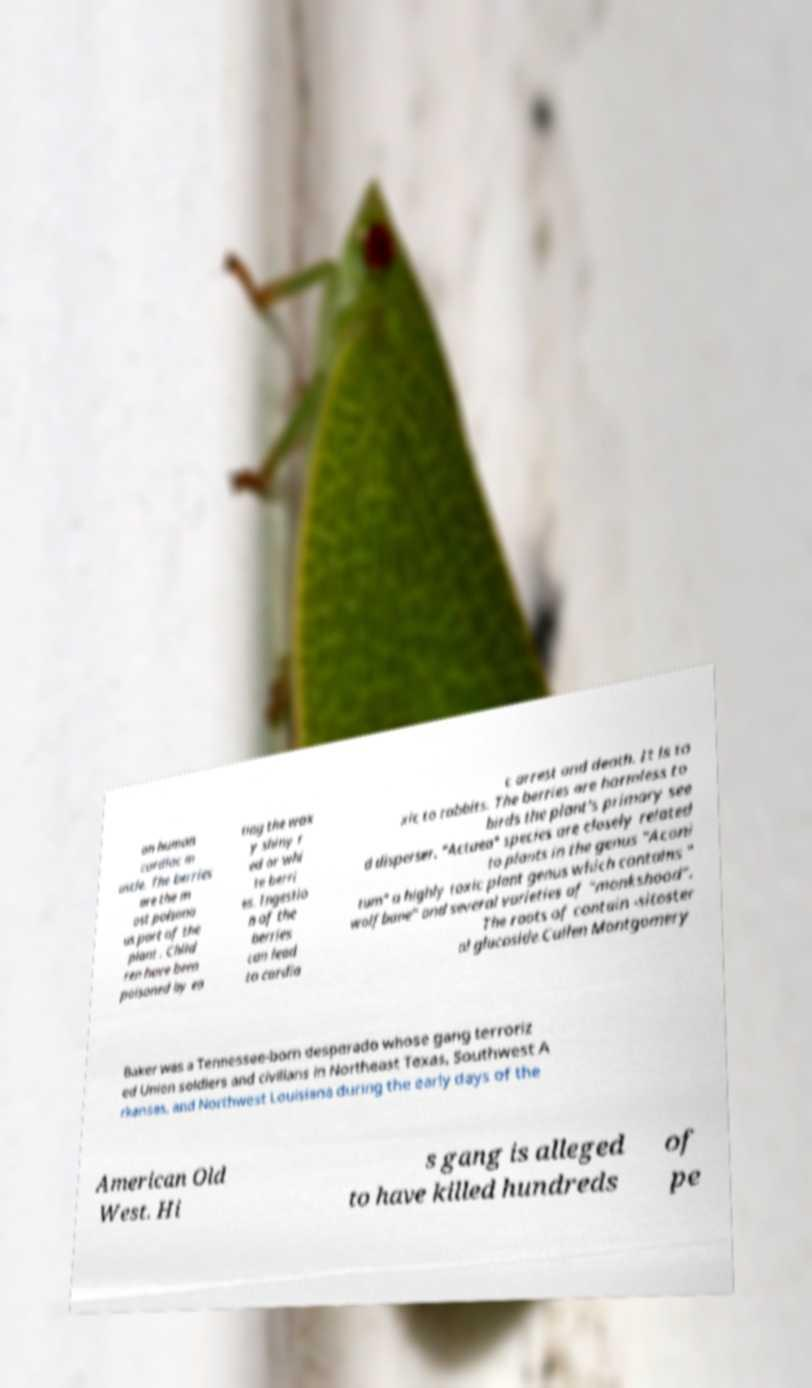Could you assist in decoding the text presented in this image and type it out clearly? on human cardiac m uscle. The berries are the m ost poisono us part of the plant . Child ren have been poisoned by ea ting the wax y shiny r ed or whi te berri es. Ingestio n of the berries can lead to cardia c arrest and death. It is to xic to rabbits. The berries are harmless to birds the plant's primary see d disperser. "Actaea" species are closely related to plants in the genus "Aconi tum" a highly toxic plant genus which contains " wolfbane" and several varieties of "monkshood". The roots of contain -sitoster ol glucoside.Cullen Montgomery Baker was a Tennessee-born desperado whose gang terroriz ed Union soldiers and civilians in Northeast Texas, Southwest A rkansas, and Northwest Louisiana during the early days of the American Old West. Hi s gang is alleged to have killed hundreds of pe 